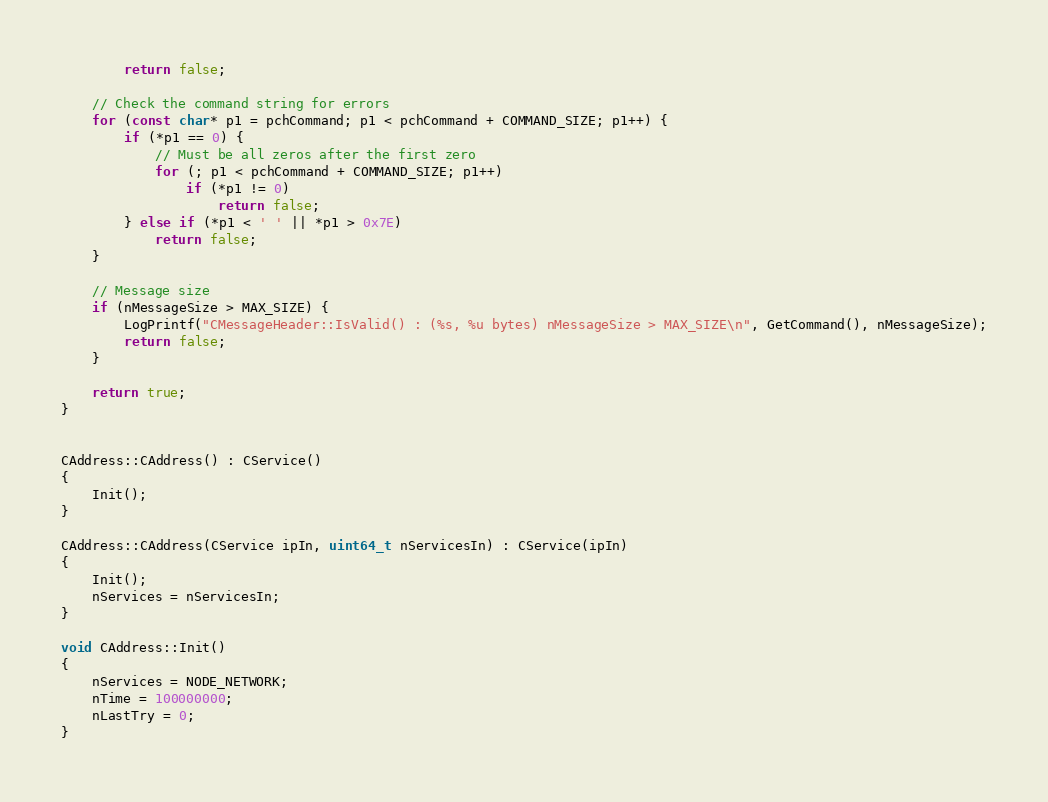<code> <loc_0><loc_0><loc_500><loc_500><_C++_>        return false;

    // Check the command string for errors
    for (const char* p1 = pchCommand; p1 < pchCommand + COMMAND_SIZE; p1++) {
        if (*p1 == 0) {
            // Must be all zeros after the first zero
            for (; p1 < pchCommand + COMMAND_SIZE; p1++)
                if (*p1 != 0)
                    return false;
        } else if (*p1 < ' ' || *p1 > 0x7E)
            return false;
    }

    // Message size
    if (nMessageSize > MAX_SIZE) {
        LogPrintf("CMessageHeader::IsValid() : (%s, %u bytes) nMessageSize > MAX_SIZE\n", GetCommand(), nMessageSize);
        return false;
    }

    return true;
}


CAddress::CAddress() : CService()
{
    Init();
}

CAddress::CAddress(CService ipIn, uint64_t nServicesIn) : CService(ipIn)
{
    Init();
    nServices = nServicesIn;
}

void CAddress::Init()
{
    nServices = NODE_NETWORK;
    nTime = 100000000;
    nLastTry = 0;
}
</code> 